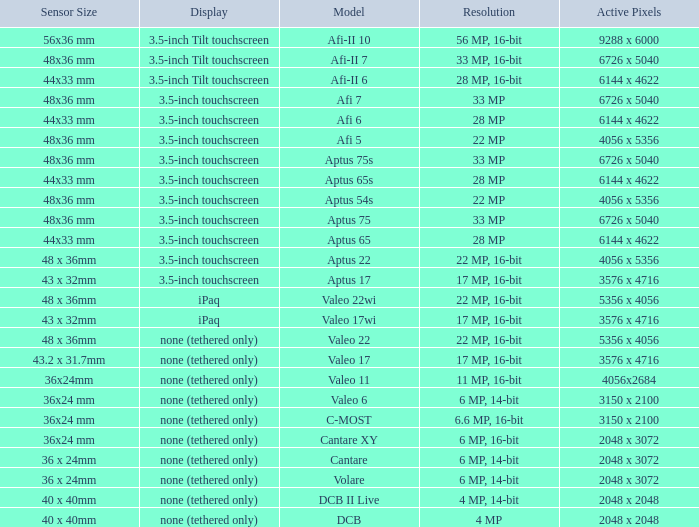What are the working pixels of the cantare model? 2048 x 3072. 